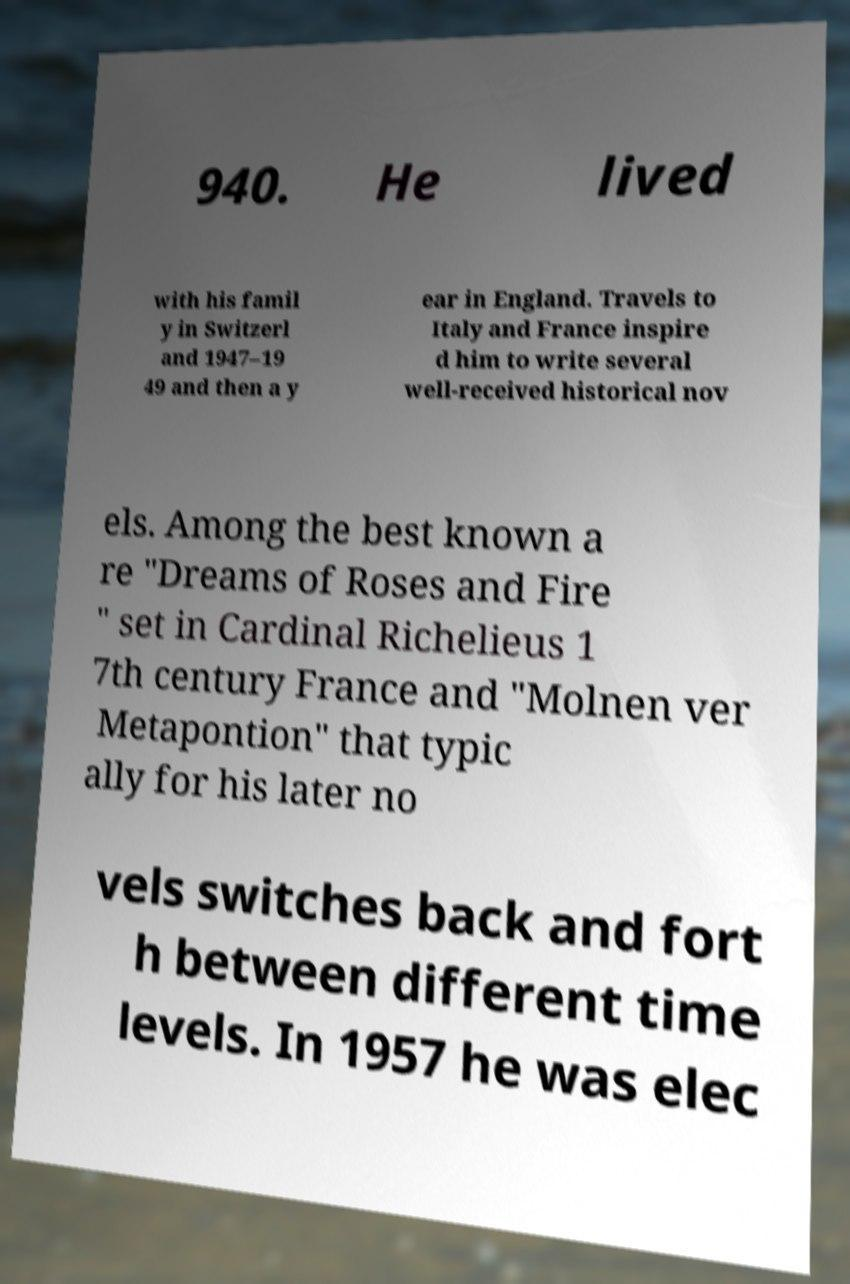For documentation purposes, I need the text within this image transcribed. Could you provide that? 940. He lived with his famil y in Switzerl and 1947–19 49 and then a y ear in England. Travels to Italy and France inspire d him to write several well-received historical nov els. Among the best known a re "Dreams of Roses and Fire " set in Cardinal Richelieus 1 7th century France and "Molnen ver Metapontion" that typic ally for his later no vels switches back and fort h between different time levels. In 1957 he was elec 